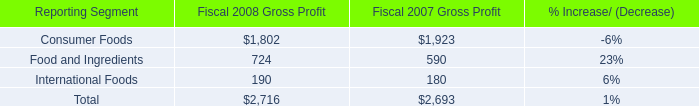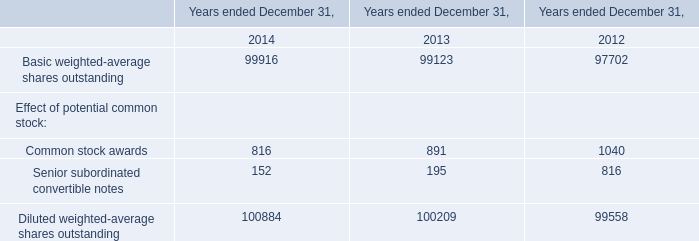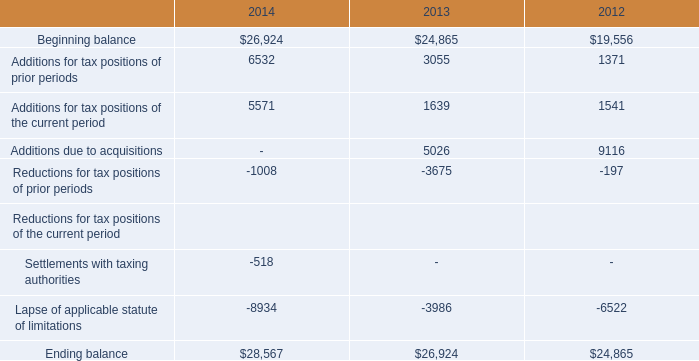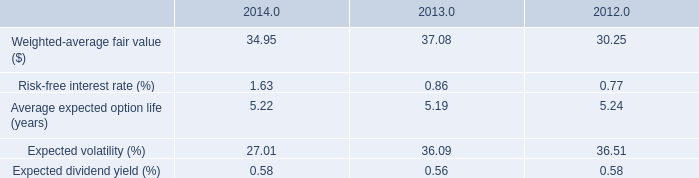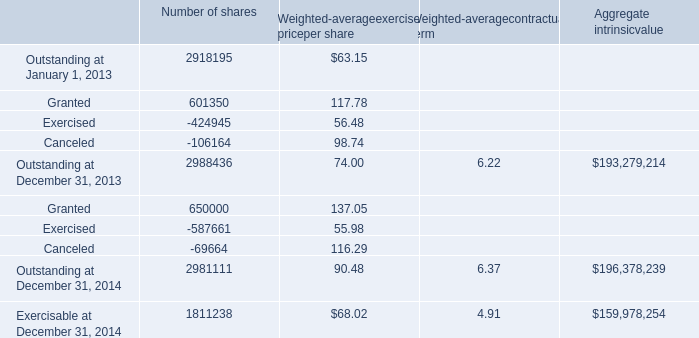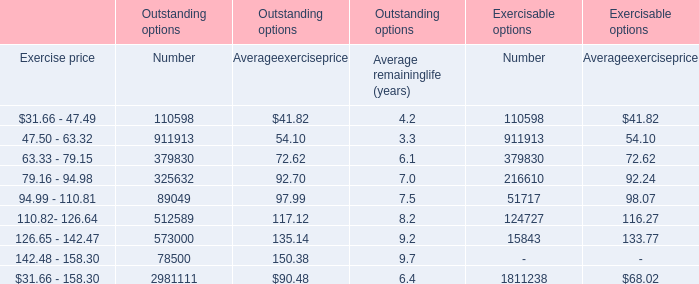Does Exercised for Weighted-average exercise price per share keeps increasing each year between 2013 and 2014? 
Answer: No. 